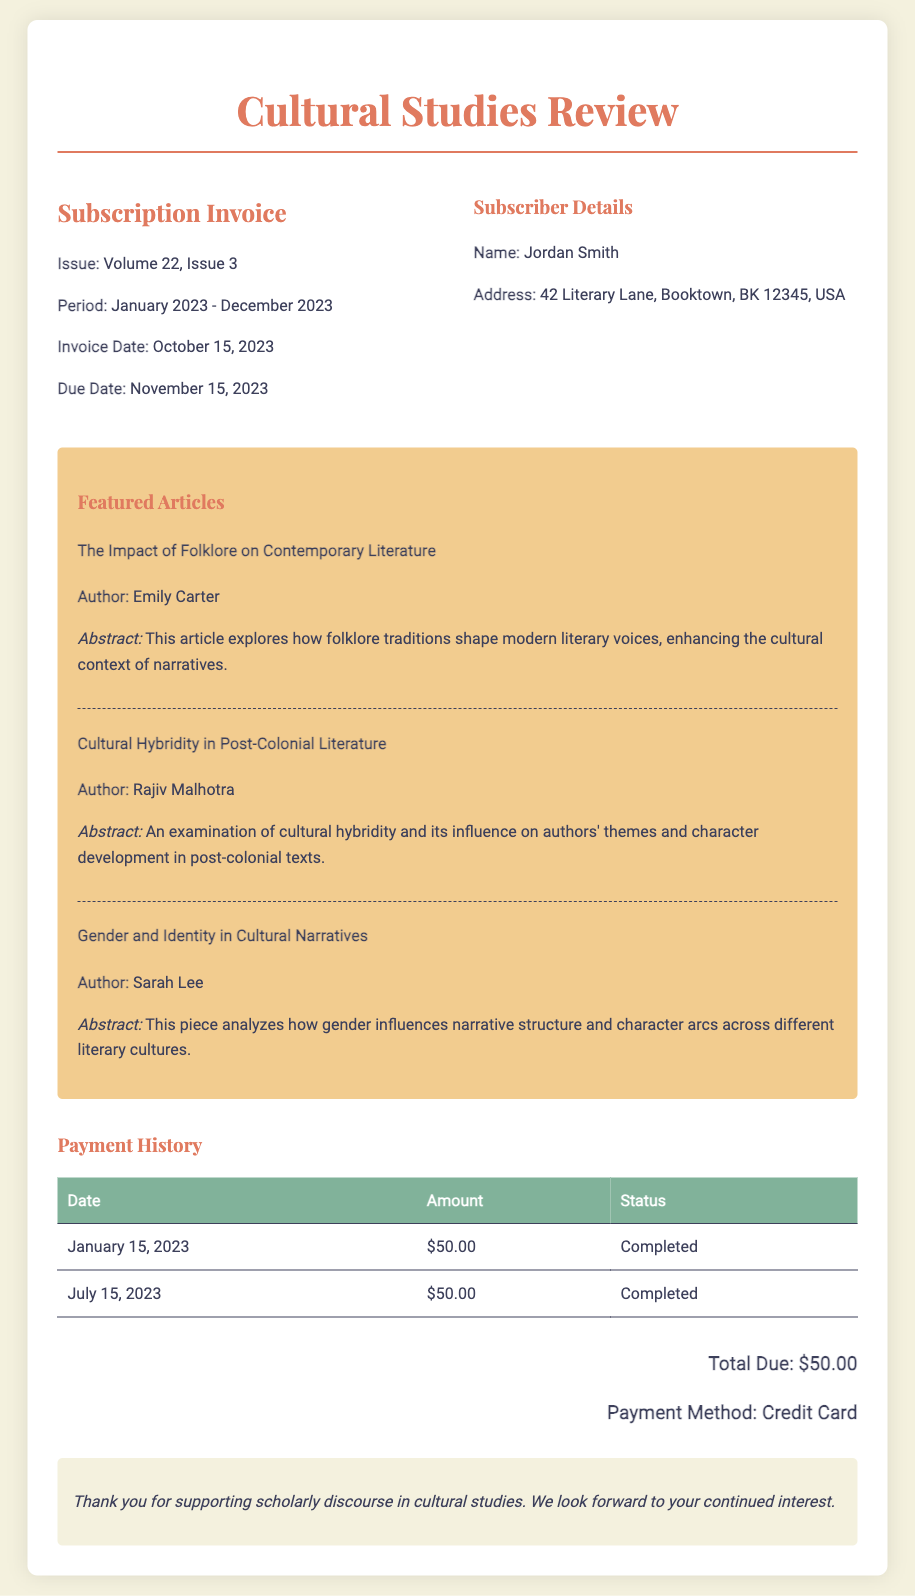What is the name of the subscriber? The subscriber's name is mentioned at the top of the document under Subscriber Details.
Answer: Jordan Smith What is the issue number of the subscription invoice? The issue number is specified right after "Subscription Invoice" in the document.
Answer: Volume 22, Issue 3 What is the total due amount? The total due is stated at the bottom of the invoice under the total due section.
Answer: $50.00 Who wrote the article "Cultural Hybridity in Post-Colonial Literature"? The author of this specific article is listed under the featured articles section of the document.
Answer: Rajiv Malhotra When is the due date for the subscription invoice? The due date is indicated clearly in the invoice details section of the document.
Answer: November 15, 2023 How many payments have been made according to the payment history? The payment history table shows the number of completed payments listed in it.
Answer: 2 What payment method was used for the subscription? The payment method is mentioned just before the notes section at the bottom of the invoice.
Answer: Credit Card What is the abstract focus of the article by Emily Carter? The abstract provides insight into the theme discussed in the article, which is highlighted in the articles section.
Answer: Folklore traditions shape modern literary voices What is the period covered by this subscription? The subscription period is stated right after the issue details in the document.
Answer: January 2023 - December 2023 